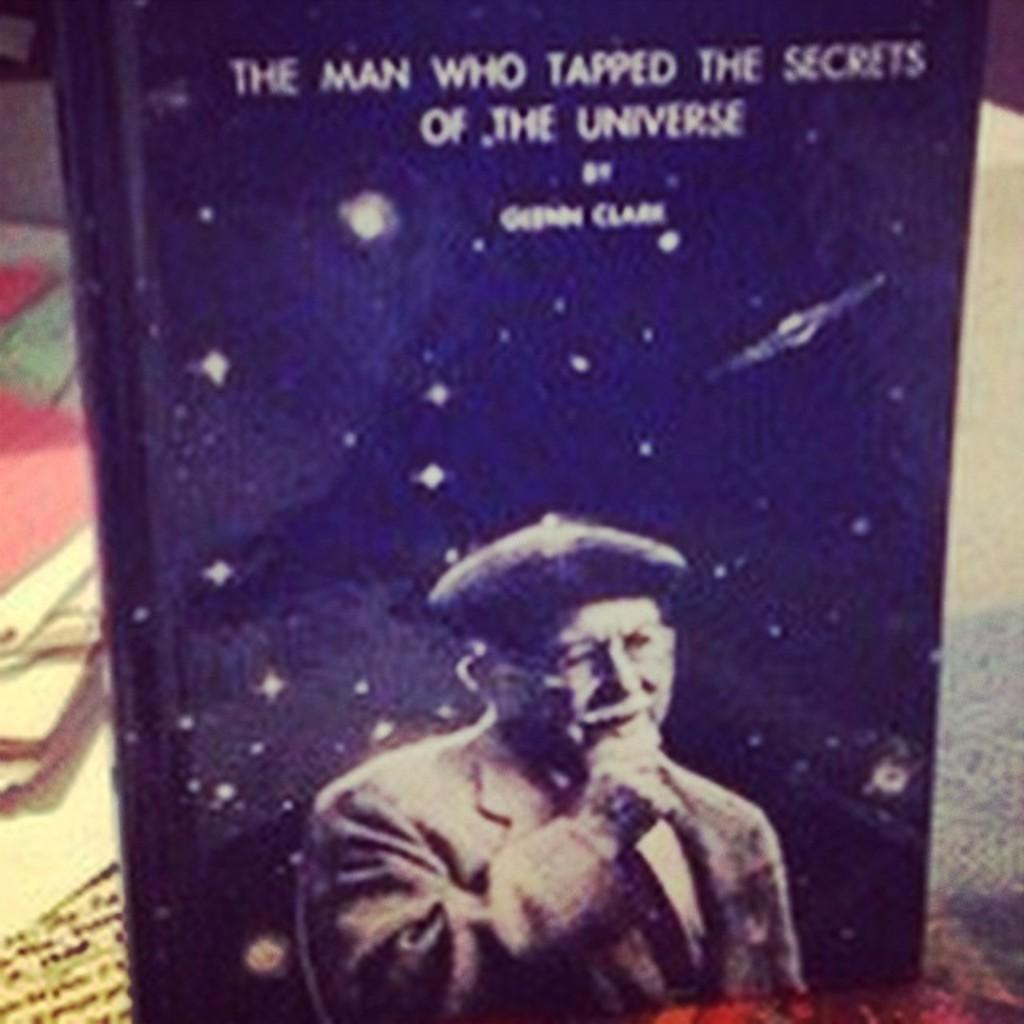<image>
Describe the image concisely. Book with a man on cover titled "The Man Who Tapped The Secrets Of The Universe". 